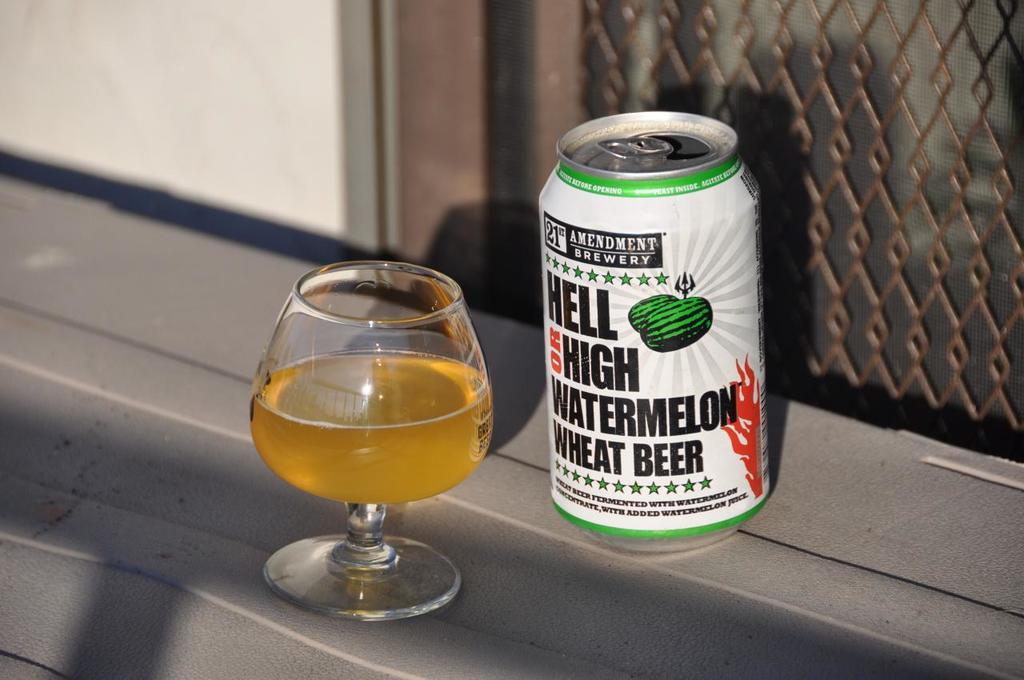What is in the glass?
Give a very brief answer. Beer. 